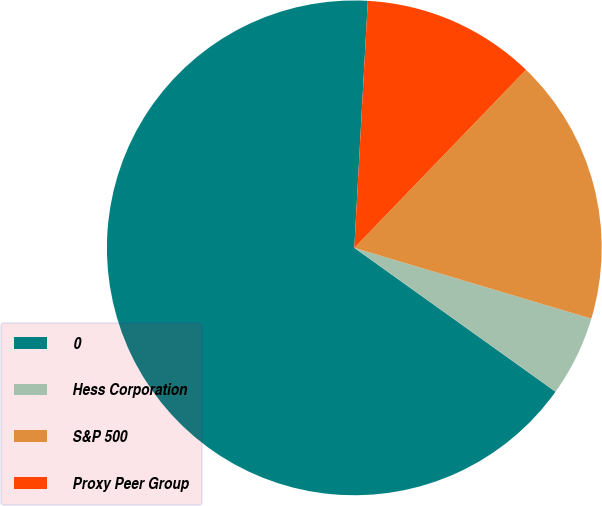Convert chart to OTSL. <chart><loc_0><loc_0><loc_500><loc_500><pie_chart><fcel>0<fcel>Hess Corporation<fcel>S&P 500<fcel>Proxy Peer Group<nl><fcel>65.99%<fcel>5.26%<fcel>17.41%<fcel>11.34%<nl></chart> 